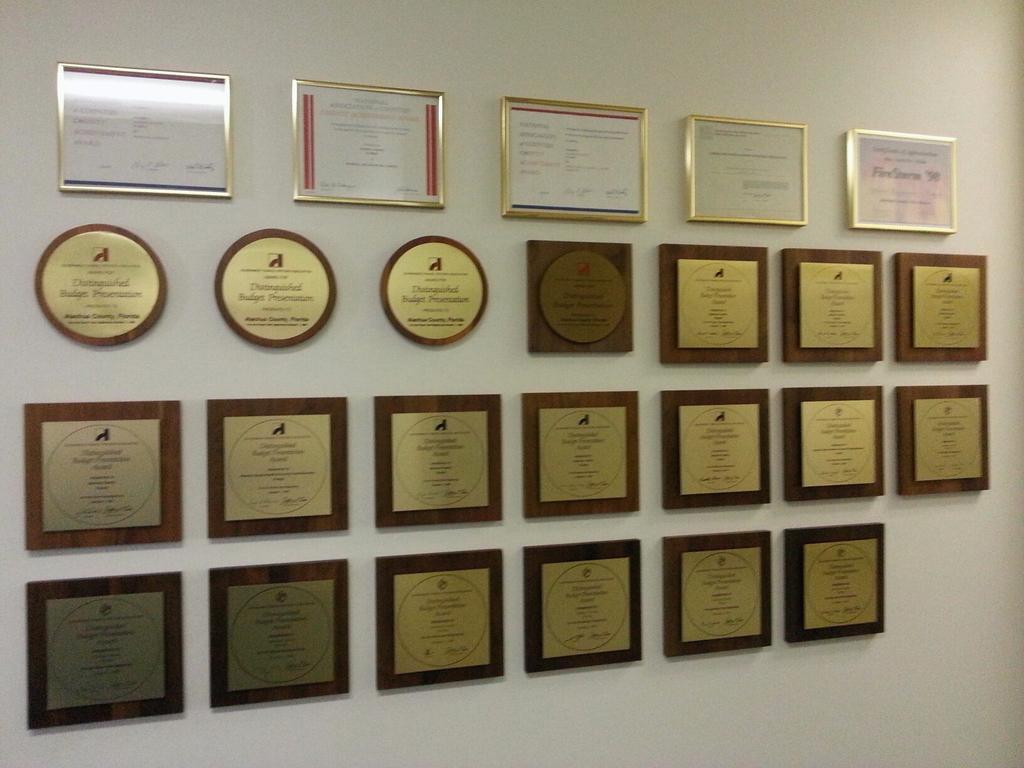In one or two sentences, can you explain what this image depicts? In this picture we can see few frames on the wall. 